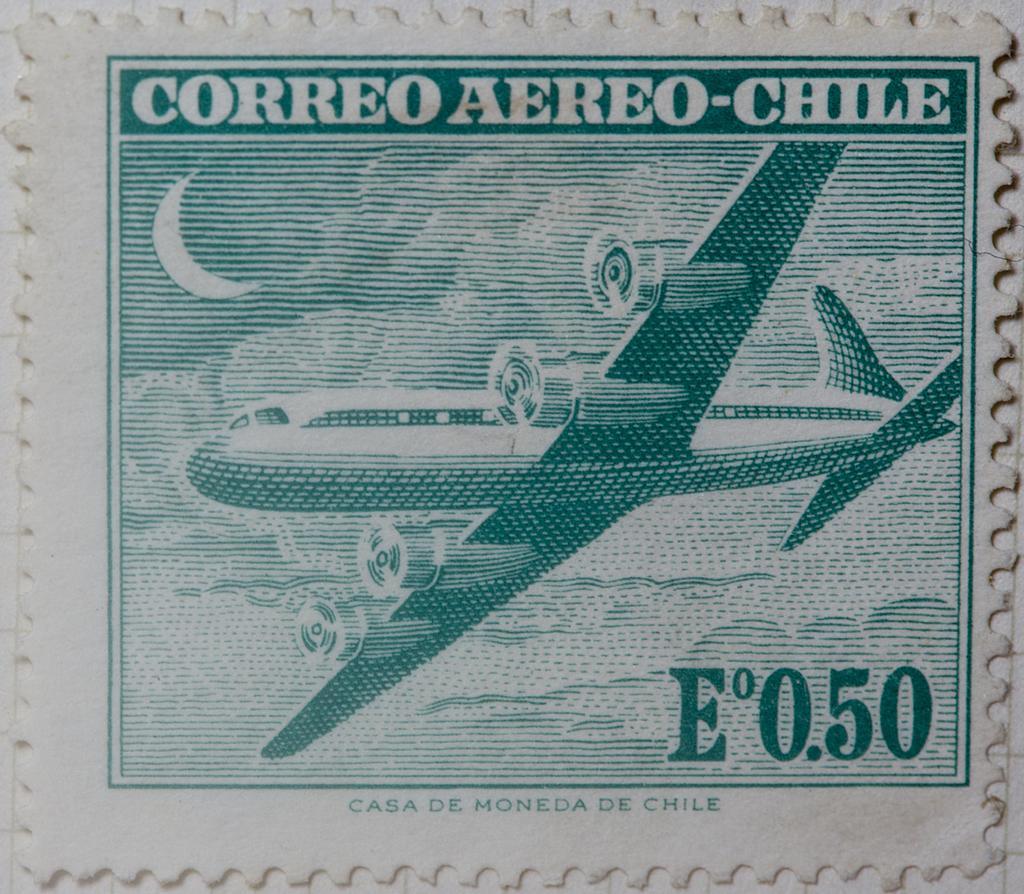In one or two sentences, can you explain what this image depicts? In the image there is a stamp with the image of airplane. 